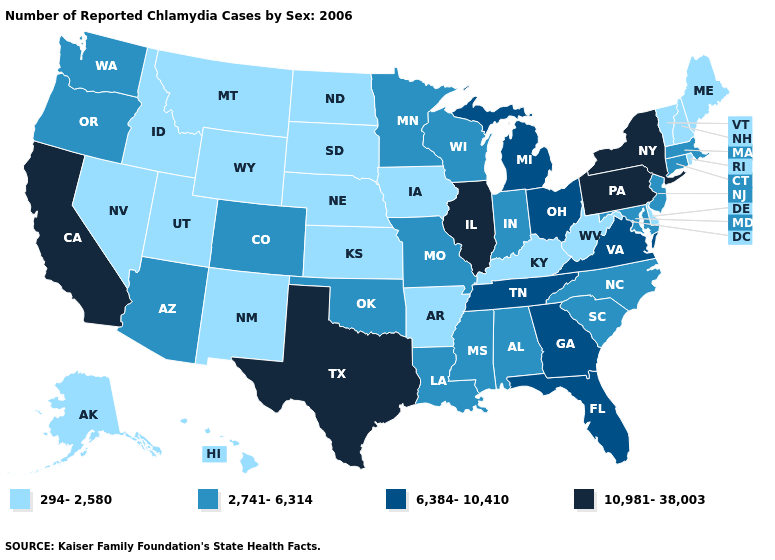What is the value of South Carolina?
Quick response, please. 2,741-6,314. What is the value of Alabama?
Answer briefly. 2,741-6,314. Does the first symbol in the legend represent the smallest category?
Be succinct. Yes. How many symbols are there in the legend?
Give a very brief answer. 4. Which states hav the highest value in the Northeast?
Short answer required. New York, Pennsylvania. Among the states that border Indiana , which have the highest value?
Concise answer only. Illinois. What is the lowest value in the USA?
Concise answer only. 294-2,580. What is the value of Georgia?
Concise answer only. 6,384-10,410. Which states have the lowest value in the MidWest?
Answer briefly. Iowa, Kansas, Nebraska, North Dakota, South Dakota. Name the states that have a value in the range 10,981-38,003?
Concise answer only. California, Illinois, New York, Pennsylvania, Texas. What is the lowest value in the USA?
Give a very brief answer. 294-2,580. Does the first symbol in the legend represent the smallest category?
Be succinct. Yes. Name the states that have a value in the range 10,981-38,003?
Answer briefly. California, Illinois, New York, Pennsylvania, Texas. Does Connecticut have the highest value in the USA?
Concise answer only. No. What is the lowest value in the Northeast?
Be succinct. 294-2,580. 